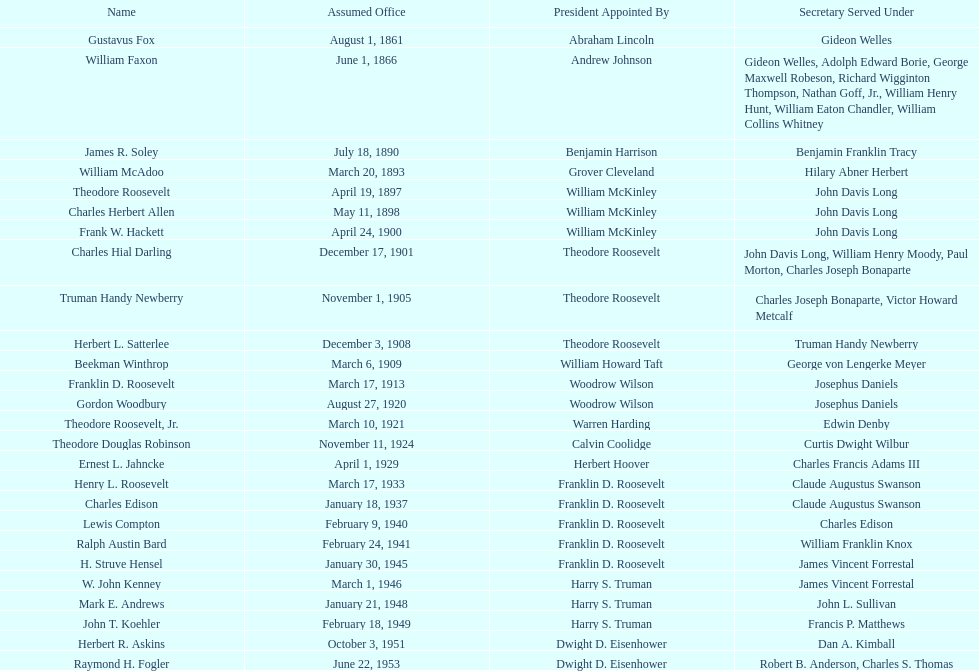Parse the table in full. {'header': ['Name', 'Assumed Office', 'President Appointed By', 'Secretary Served Under'], 'rows': [['Gustavus Fox', 'August 1, 1861', 'Abraham Lincoln', 'Gideon Welles'], ['William Faxon', 'June 1, 1866', 'Andrew Johnson', 'Gideon Welles, Adolph Edward Borie, George Maxwell Robeson, Richard Wigginton Thompson, Nathan Goff, Jr., William Henry Hunt, William Eaton Chandler, William Collins Whitney'], ['James R. Soley', 'July 18, 1890', 'Benjamin Harrison', 'Benjamin Franklin Tracy'], ['William McAdoo', 'March 20, 1893', 'Grover Cleveland', 'Hilary Abner Herbert'], ['Theodore Roosevelt', 'April 19, 1897', 'William McKinley', 'John Davis Long'], ['Charles Herbert Allen', 'May 11, 1898', 'William McKinley', 'John Davis Long'], ['Frank W. Hackett', 'April 24, 1900', 'William McKinley', 'John Davis Long'], ['Charles Hial Darling', 'December 17, 1901', 'Theodore Roosevelt', 'John Davis Long, William Henry Moody, Paul Morton, Charles Joseph Bonaparte'], ['Truman Handy Newberry', 'November 1, 1905', 'Theodore Roosevelt', 'Charles Joseph Bonaparte, Victor Howard Metcalf'], ['Herbert L. Satterlee', 'December 3, 1908', 'Theodore Roosevelt', 'Truman Handy Newberry'], ['Beekman Winthrop', 'March 6, 1909', 'William Howard Taft', 'George von Lengerke Meyer'], ['Franklin D. Roosevelt', 'March 17, 1913', 'Woodrow Wilson', 'Josephus Daniels'], ['Gordon Woodbury', 'August 27, 1920', 'Woodrow Wilson', 'Josephus Daniels'], ['Theodore Roosevelt, Jr.', 'March 10, 1921', 'Warren Harding', 'Edwin Denby'], ['Theodore Douglas Robinson', 'November 11, 1924', 'Calvin Coolidge', 'Curtis Dwight Wilbur'], ['Ernest L. Jahncke', 'April 1, 1929', 'Herbert Hoover', 'Charles Francis Adams III'], ['Henry L. Roosevelt', 'March 17, 1933', 'Franklin D. Roosevelt', 'Claude Augustus Swanson'], ['Charles Edison', 'January 18, 1937', 'Franklin D. Roosevelt', 'Claude Augustus Swanson'], ['Lewis Compton', 'February 9, 1940', 'Franklin D. Roosevelt', 'Charles Edison'], ['Ralph Austin Bard', 'February 24, 1941', 'Franklin D. Roosevelt', 'William Franklin Knox'], ['H. Struve Hensel', 'January 30, 1945', 'Franklin D. Roosevelt', 'James Vincent Forrestal'], ['W. John Kenney', 'March 1, 1946', 'Harry S. Truman', 'James Vincent Forrestal'], ['Mark E. Andrews', 'January 21, 1948', 'Harry S. Truman', 'John L. Sullivan'], ['John T. Koehler', 'February 18, 1949', 'Harry S. Truman', 'Francis P. Matthews'], ['Herbert R. Askins', 'October 3, 1951', 'Dwight D. Eisenhower', 'Dan A. Kimball'], ['Raymond H. Fogler', 'June 22, 1953', 'Dwight D. Eisenhower', 'Robert B. Anderson, Charles S. Thomas']]} Who was the first assistant secretary of the navy? Gustavus Fox. 